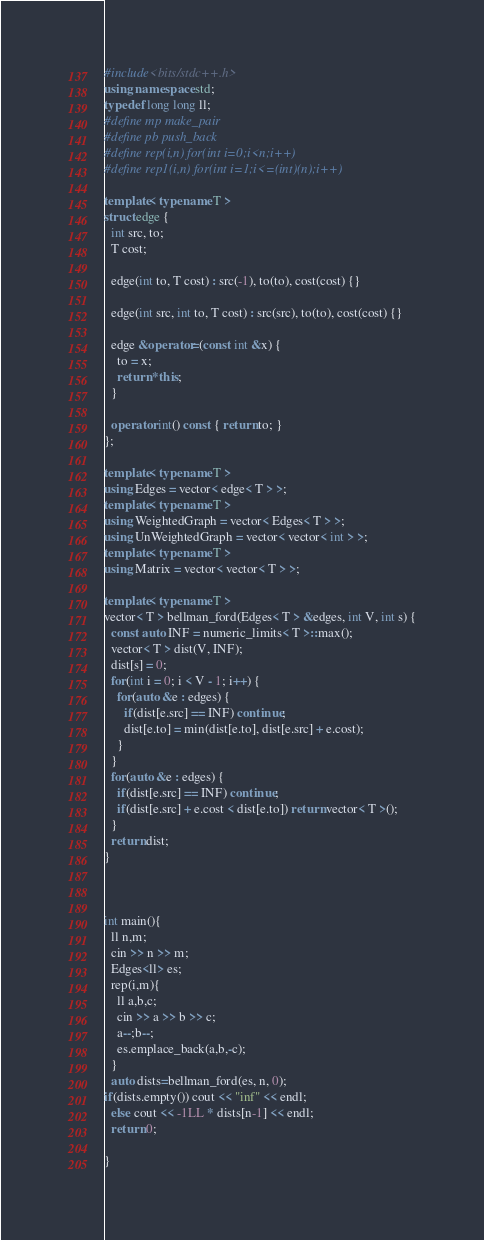<code> <loc_0><loc_0><loc_500><loc_500><_C++_>#include<bits/stdc++.h>
using namespace std;
typedef long long ll;
#define mp make_pair
#define pb push_back
#define rep(i,n) for(int i=0;i<n;i++)
#define rep1(i,n) for(int i=1;i<=(int)(n);i++)

template< typename T >
struct edge {
  int src, to;
  T cost;

  edge(int to, T cost) : src(-1), to(to), cost(cost) {}

  edge(int src, int to, T cost) : src(src), to(to), cost(cost) {}

  edge &operator=(const int &x) {
    to = x;
    return *this;
  }

  operator int() const { return to; }
};

template< typename T >
using Edges = vector< edge< T > >;
template< typename T >
using WeightedGraph = vector< Edges< T > >;
using UnWeightedGraph = vector< vector< int > >;
template< typename T >
using Matrix = vector< vector< T > >;

template< typename T >
vector< T > bellman_ford(Edges< T > &edges, int V, int s) {
  const auto INF = numeric_limits< T >::max();
  vector< T > dist(V, INF);
  dist[s] = 0;
  for(int i = 0; i < V - 1; i++) {
    for(auto &e : edges) {
      if(dist[e.src] == INF) continue;
      dist[e.to] = min(dist[e.to], dist[e.src] + e.cost);
    }
  }
  for(auto &e : edges) {
    if(dist[e.src] == INF) continue;
    if(dist[e.src] + e.cost < dist[e.to]) return vector< T >();
  }
  return dist;
}



int main(){
  ll n,m;
  cin >> n >> m;
  Edges<ll> es;
  rep(i,m){
    ll a,b,c;
    cin >> a >> b >> c;
    a--;b--;
    es.emplace_back(a,b,-c);
  }  
  auto dists=bellman_ford(es, n, 0);
if(dists.empty()) cout << "inf" << endl;
  else cout << -1LL * dists[n-1] << endl;
  return 0;

}
</code> 